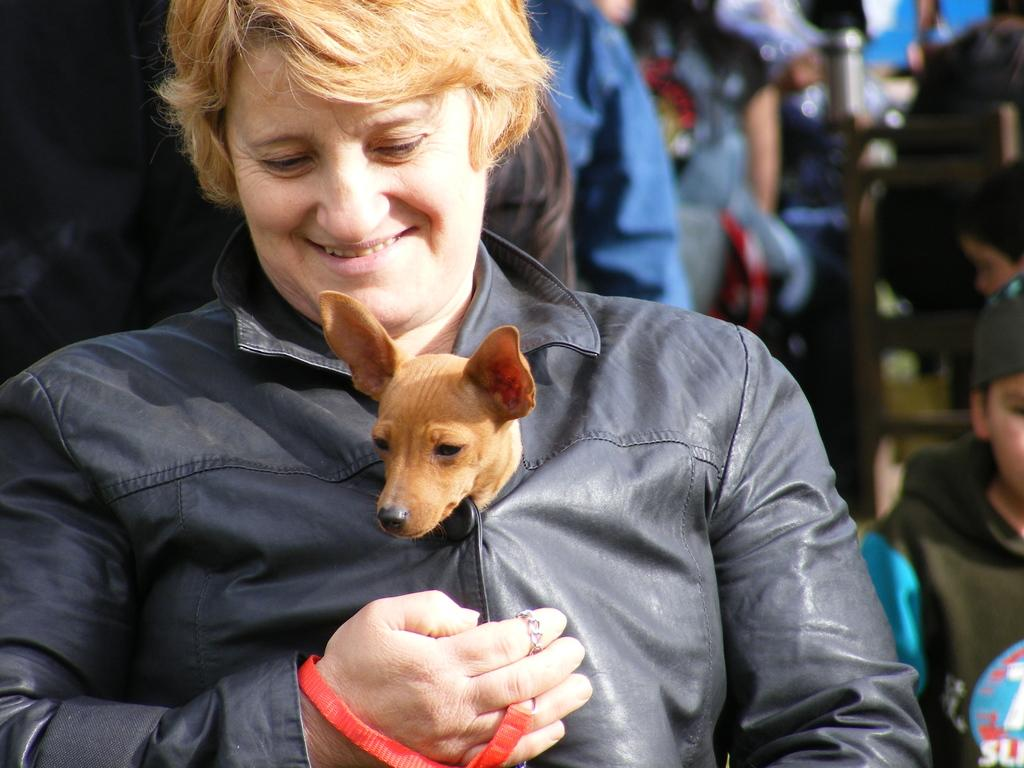Who is present in the image? There is a woman in the image. What is the woman doing in the image? The woman is smiling in the image. Can you describe the unusual aspect of the woman's attire? There is a dog in the woman's clothes. What can be seen in the background of the image? There are people visible in the background of the image. How many legs does the letter have in the image? There is no letter present in the image, so it is not possible to determine the number of legs it might have. 